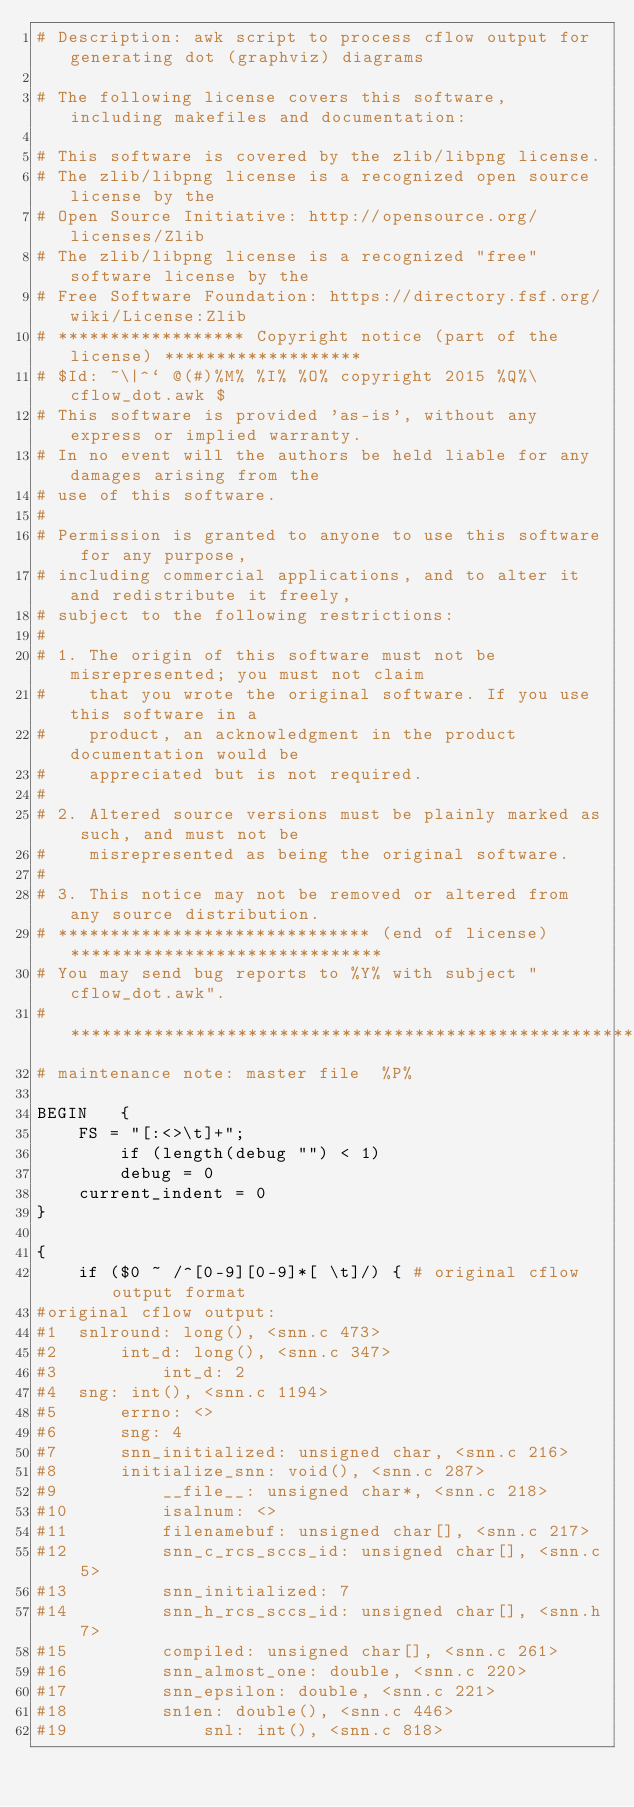<code> <loc_0><loc_0><loc_500><loc_500><_Awk_># Description: awk script to process cflow output for generating dot (graphviz) diagrams

# The following license covers this software, including makefiles and documentation:

# This software is covered by the zlib/libpng license.
# The zlib/libpng license is a recognized open source license by the
# Open Source Initiative: http://opensource.org/licenses/Zlib
# The zlib/libpng license is a recognized "free" software license by the
# Free Software Foundation: https://directory.fsf.org/wiki/License:Zlib
# ****************** Copyright notice (part of the license) *******************
# $Id: ~\|^` @(#)%M% %I% %O% copyright 2015 %Q%\ cflow_dot.awk $
# This software is provided 'as-is', without any express or implied warranty.
# In no event will the authors be held liable for any damages arising from the
# use of this software.
#
# Permission is granted to anyone to use this software for any purpose,
# including commercial applications, and to alter it and redistribute it freely,
# subject to the following restrictions:
#
# 1. The origin of this software must not be misrepresented; you must not claim
#    that you wrote the original software. If you use this software in a
#    product, an acknowledgment in the product documentation would be
#    appreciated but is not required.
#
# 2. Altered source versions must be plainly marked as such, and must not be
#    misrepresented as being the original software.
#
# 3. This notice may not be removed or altered from any source distribution.
# ****************************** (end of license) ******************************
# You may send bug reports to %Y% with subject "cflow_dot.awk".
# *****************************************************************************
# maintenance note: master file  %P%

BEGIN	{
	FS = "[:<>\t]+";
        if (length(debug "") < 1)
		debug = 0
	current_indent = 0
}

{
	if ($0 ~ /^[0-9][0-9]*[ \t]/) { # original cflow output format
#original cflow output:
#1	snlround: long(), <snn.c 473>
#2		int_d: long(), <snn.c 347>
#3			int_d: 2
#4	sng: int(), <snn.c 1194>
#5		errno: <>
#6		sng: 4
#7		snn_initialized: unsigned char, <snn.c 216>
#8		initialize_snn: void(), <snn.c 287>
#9			__file__: unsigned char*, <snn.c 218>
#10			isalnum: <>
#11			filenamebuf: unsigned char[], <snn.c 217>
#12			snn_c_rcs_sccs_id: unsigned char[], <snn.c 5>
#13			snn_initialized: 7
#14			snn_h_rcs_sccs_id: unsigned char[], <snn.h 7>
#15			compiled: unsigned char[], <snn.c 261>
#16			snn_almost_one: double, <snn.c 220>
#17			snn_epsilon: double, <snn.c 221>
#18			sn1en: double(), <snn.c 446>
#19				snl: int(), <snn.c 818></code> 